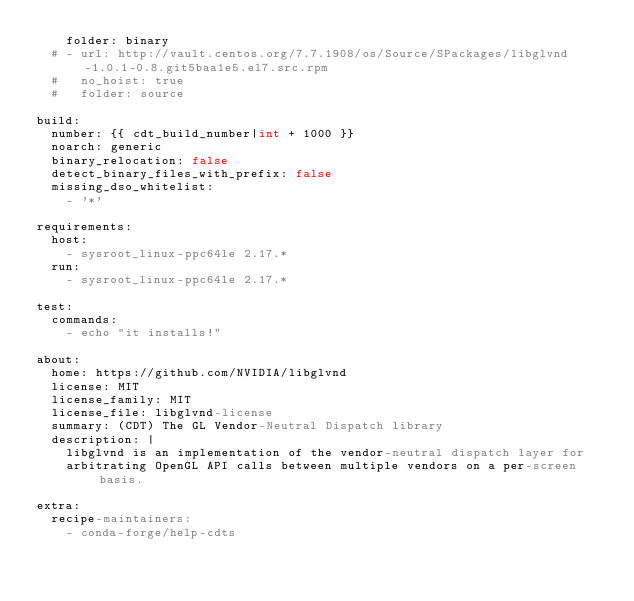<code> <loc_0><loc_0><loc_500><loc_500><_YAML_>    folder: binary
  # - url: http://vault.centos.org/7.7.1908/os/Source/SPackages/libglvnd-1.0.1-0.8.git5baa1e5.el7.src.rpm
  #   no_hoist: true
  #   folder: source

build:
  number: {{ cdt_build_number|int + 1000 }}
  noarch: generic
  binary_relocation: false
  detect_binary_files_with_prefix: false
  missing_dso_whitelist:
    - '*'

requirements:
  host:
    - sysroot_linux-ppc64le 2.17.*
  run:
    - sysroot_linux-ppc64le 2.17.*

test:
  commands:
    - echo "it installs!"

about:
  home: https://github.com/NVIDIA/libglvnd
  license: MIT
  license_family: MIT
  license_file: libglvnd-license
  summary: (CDT) The GL Vendor-Neutral Dispatch library
  description: |
    libglvnd is an implementation of the vendor-neutral dispatch layer for
    arbitrating OpenGL API calls between multiple vendors on a per-screen basis.

extra:
  recipe-maintainers:
    - conda-forge/help-cdts
</code> 